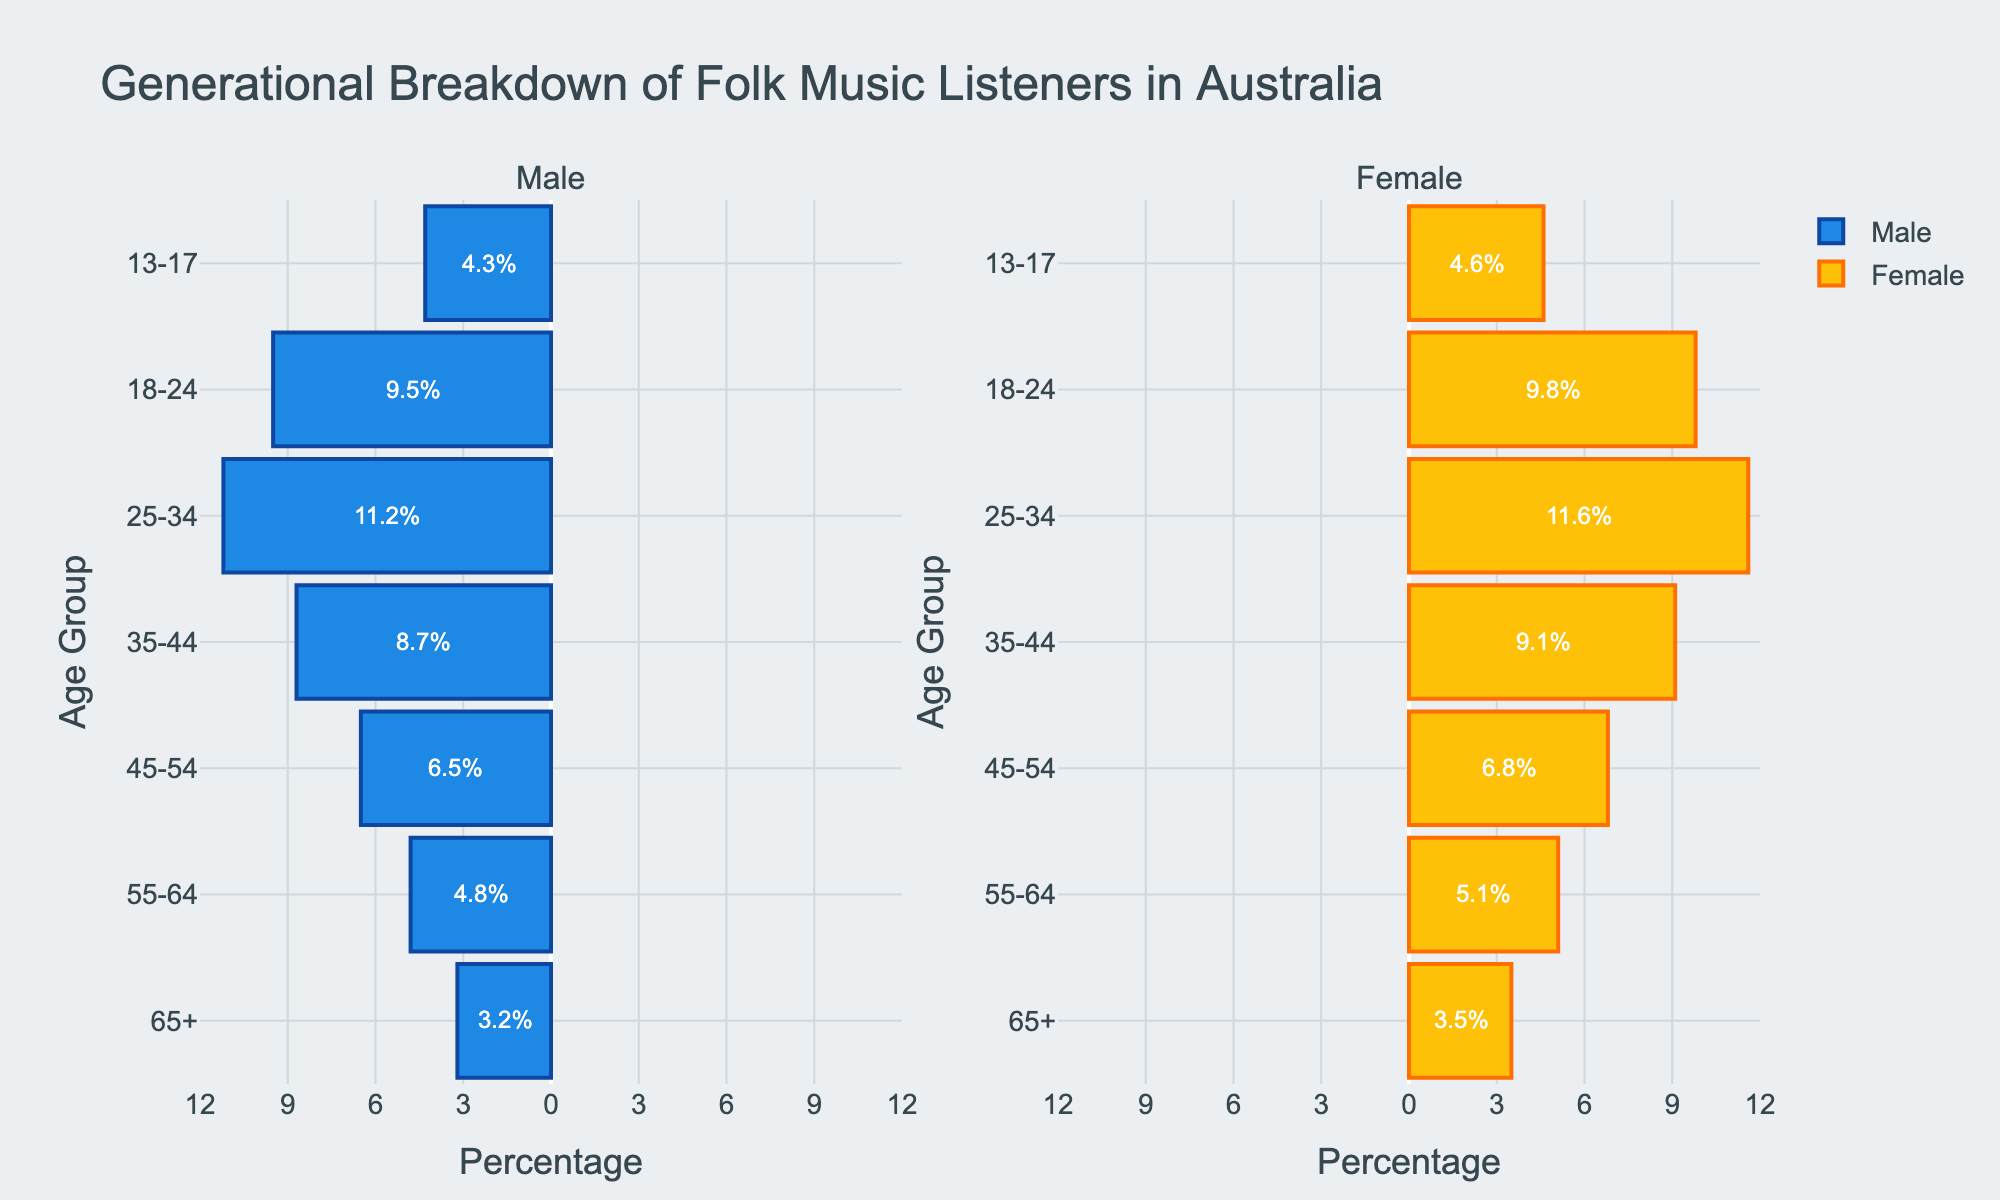What's the title of the figure? The title of the figure is positioned at the top center and provides an overview of the content. Reading it gives insight into what the data represents.
Answer: Generational Breakdown of Folk Music Listeners in Australia Which age group has the highest percentage of female listeners? To find this, look for the longest bar on the female side of the pyramid. The age-group label corresponding to this bar will be the answer.
Answer: 25-34 Are there more male or female listeners aged 18-24? Compare the lengths of the male and female bars for the 18-24 age group. The longer bar indicates which gender has more listeners.
Answer: Female What's the total percentage of listeners in the age group 25-34? Sum the percentages of male and female listeners in the 25-34 age group.
Answer: 22.8% Which gender has more listeners aged 55-64? Compare the lengths of the male and female bars for the 55-64 age group. The longer bar indicates which gender has more listeners.
Answer: Female What's the difference in percentage between male and female listeners aged 35-44? Subtract the percentage of male listeners from that of female listeners in the 35-44 age group.
Answer: 0.4% In which age group is the gender distribution most balanced? Look for the age group where the male and female bars are closest in length. The age group with the smallest difference between male and female percentages is the answer.
Answer: 13-17 Which age group represents the smallest percentage of listeners combined? Sum the percentages of all age groups and identify the one with the smallest sum.
Answer: 65+ What's the trend in the percentage of listeners as age increases? Observe if the bars tend to get longer or shorter as you move from younger to older age groups.
Answer: Decreasing Which age group has the most significant disparity between male and female listeners? Identify the age group with the largest difference between the lengths of the male and female bars.
Answer: 65+ 